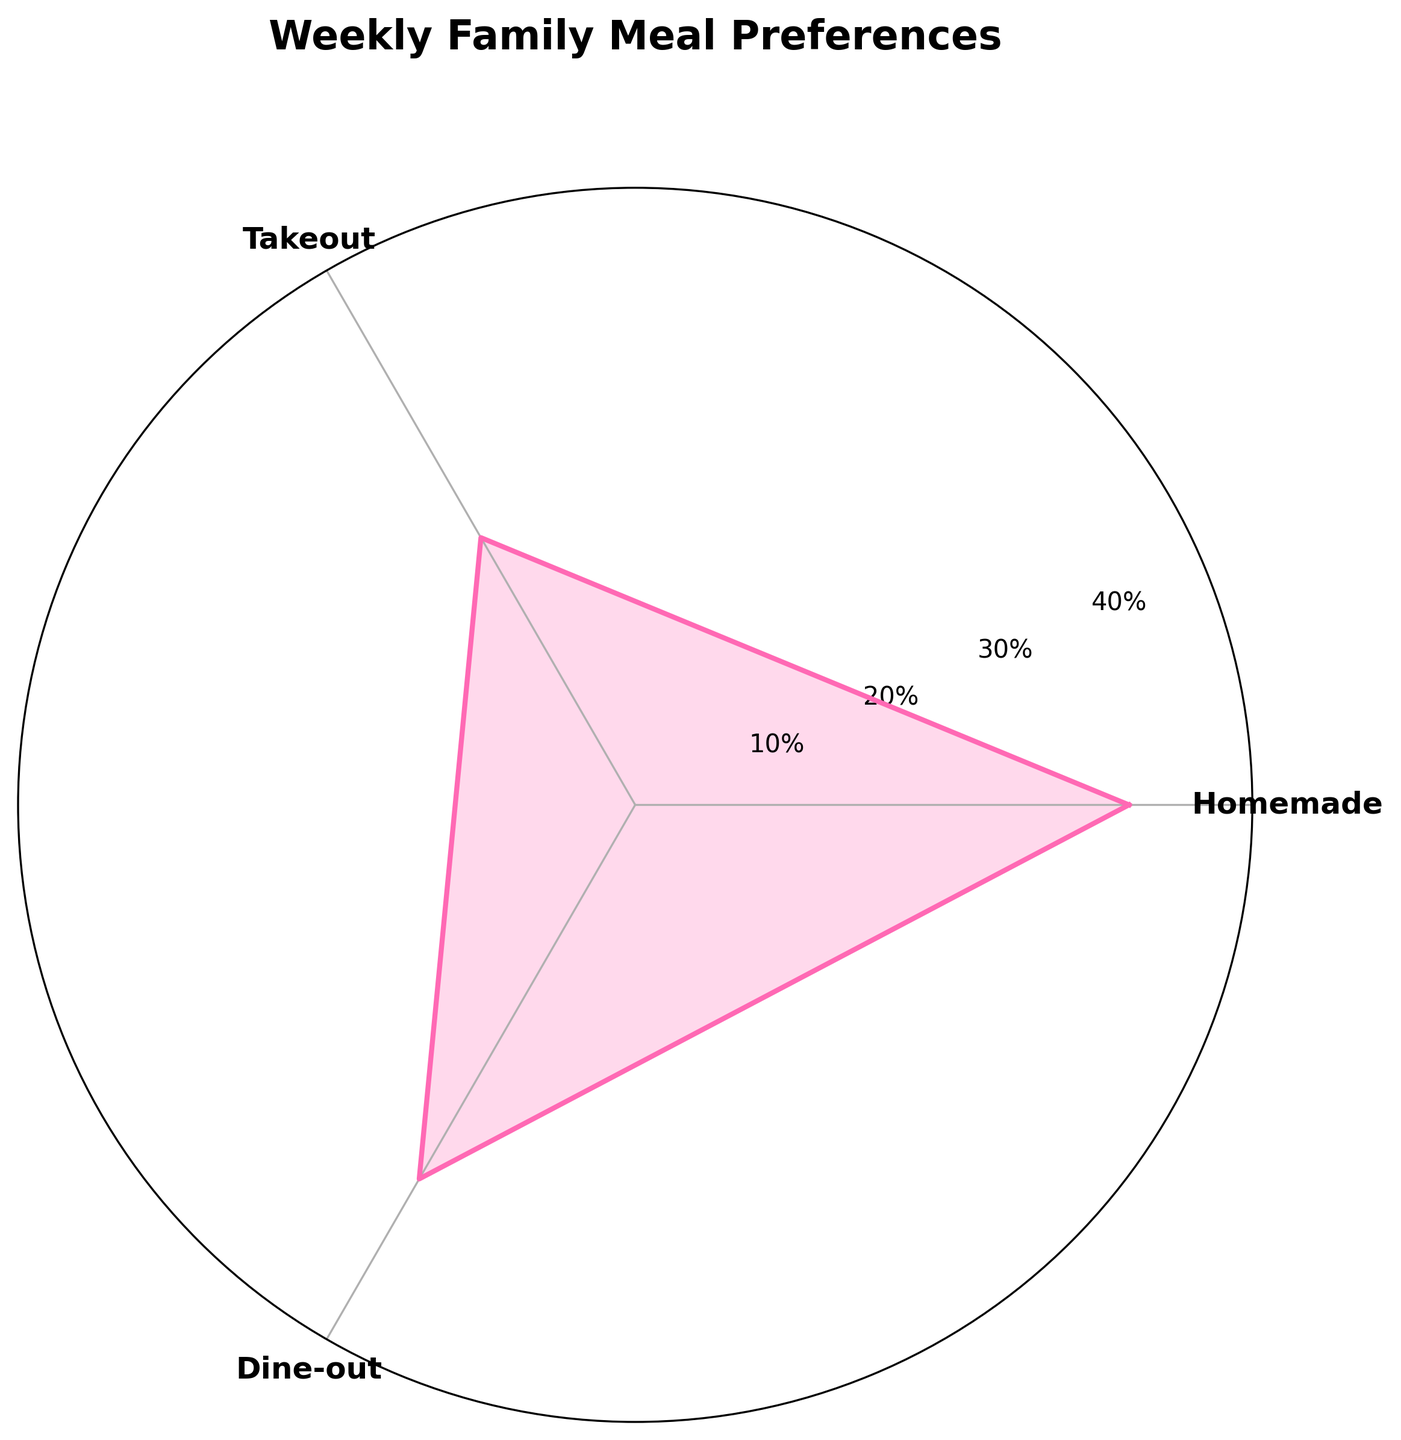What is the title of the chart? The title is typically located at the top of the chart and it helps to understand the subject the chart is depicting.
Answer: Weekly Family Meal Preferences Which category has the highest percentage in the chart? By looking at the lengths of the sections in the rose chart, the longest one represents the highest percentage.
Answer: Homemade What is the combined percentage of Dine-out and Frozen Meals? The rose chart shows individual percentages for each category. Add the percentages of Dine-out (20%) and Frozen Meals (15%) to find the combined percentage. Adding them gives 20% + 15% = 35%.
Answer: 35% How many categories are displayed in the chart? Counting the distinct labels around the rose chart will provide the number of different meal preferences shown.
Answer: 3 Which category has a smaller percentage: Takeout or Dine-out? The chart allows easy comparison of segment lengths representing percentages, where shorter segments indicate smaller values.
Answer: Dine-out What is the percentage difference between Homemade and Takeout? Subtract the percentage of Takeout (25%) from the percentage of Homemade (40%) to find the difference. The computation is 40% - 25% = 15%.
Answer: 15% Which category has the smallest percentage? The segment with the shortest length in the rose chart corresponds to the smallest percentage.
Answer: Frozen Meals What is the combined percentage of Homemade and Takeout? The rose chart provides individual percentages for each category. Adding the percentages for Homemade (40%) and Takeout (25%) results in the combined percentage, which is 40% + 25% = 65%.
Answer: 65% Between Takeout and Frozen Meals, which has a higher percentage and by how much? Comparing the lengths of the segments for Takeout and Frozen Meals shows that Takeout has a higher percentage. The difference can be calculated as Takeout (25%) - Frozen Meals (15%) = 10%.
Answer: Takeout by 10% 